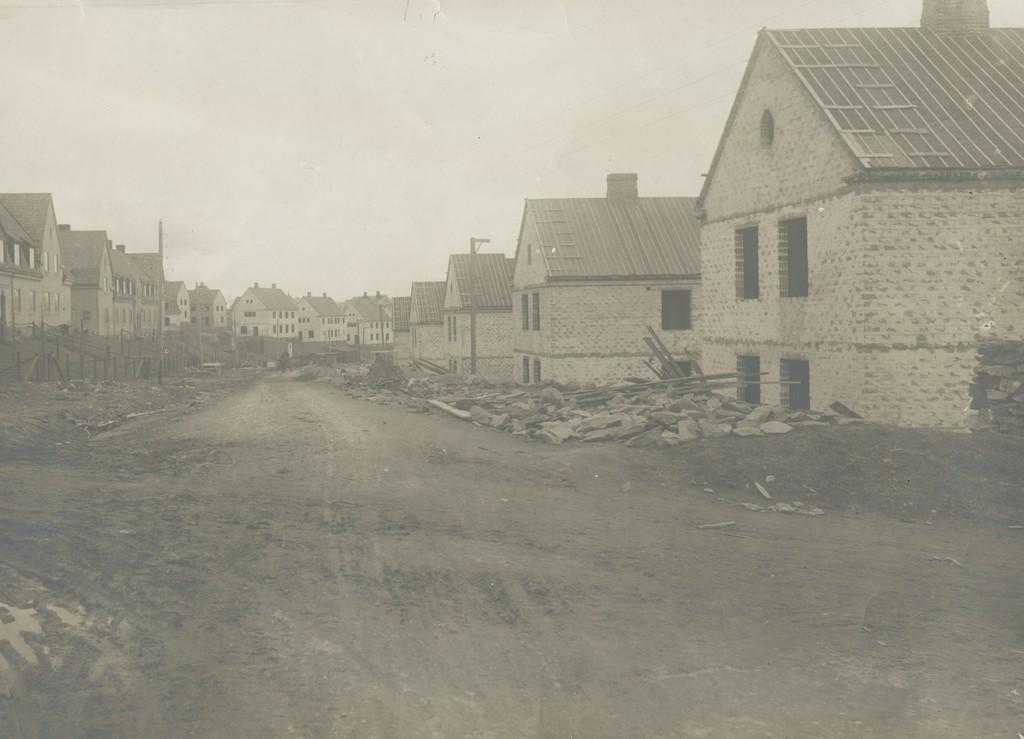What can be seen at the base of the image? The ground is visible in the image. What type of natural elements are present in the image? There are stones and sticks in the image. What man-made structures can be seen in the image? There are poles and buildings with windows in the image. What is visible in the background of the image? The sky is visible in the background of the image. Can you tell me how many times the person sneezes in the image? There is no person present in the image, and therefore no sneezing can be observed. What color is the blood on the ground in the image? There is no blood present in the image; it only features stones, sticks, poles, buildings, and the sky. 